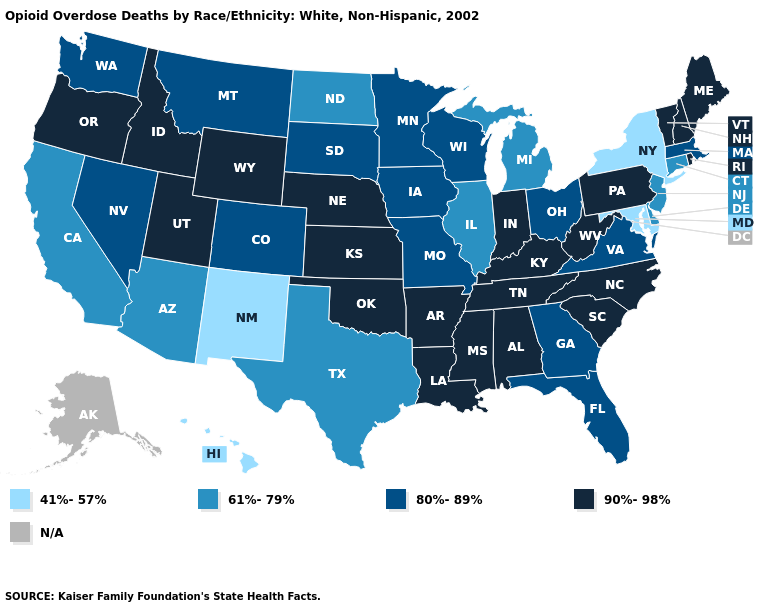What is the highest value in states that border Colorado?
Quick response, please. 90%-98%. Name the states that have a value in the range 80%-89%?
Be succinct. Colorado, Florida, Georgia, Iowa, Massachusetts, Minnesota, Missouri, Montana, Nevada, Ohio, South Dakota, Virginia, Washington, Wisconsin. Name the states that have a value in the range N/A?
Short answer required. Alaska. Name the states that have a value in the range 90%-98%?
Give a very brief answer. Alabama, Arkansas, Idaho, Indiana, Kansas, Kentucky, Louisiana, Maine, Mississippi, Nebraska, New Hampshire, North Carolina, Oklahoma, Oregon, Pennsylvania, Rhode Island, South Carolina, Tennessee, Utah, Vermont, West Virginia, Wyoming. Name the states that have a value in the range 90%-98%?
Answer briefly. Alabama, Arkansas, Idaho, Indiana, Kansas, Kentucky, Louisiana, Maine, Mississippi, Nebraska, New Hampshire, North Carolina, Oklahoma, Oregon, Pennsylvania, Rhode Island, South Carolina, Tennessee, Utah, Vermont, West Virginia, Wyoming. What is the value of Colorado?
Be succinct. 80%-89%. What is the value of Kentucky?
Answer briefly. 90%-98%. Among the states that border Utah , which have the lowest value?
Answer briefly. New Mexico. Does the first symbol in the legend represent the smallest category?
Keep it brief. Yes. What is the value of Louisiana?
Write a very short answer. 90%-98%. Does Maryland have the lowest value in the South?
Concise answer only. Yes. Name the states that have a value in the range N/A?
Give a very brief answer. Alaska. What is the value of Minnesota?
Quick response, please. 80%-89%. Among the states that border Connecticut , does Massachusetts have the highest value?
Concise answer only. No. What is the value of New York?
Keep it brief. 41%-57%. 